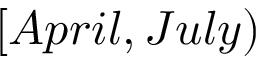Convert formula to latex. <formula><loc_0><loc_0><loc_500><loc_500>[ A p r i l , J u l y )</formula> 